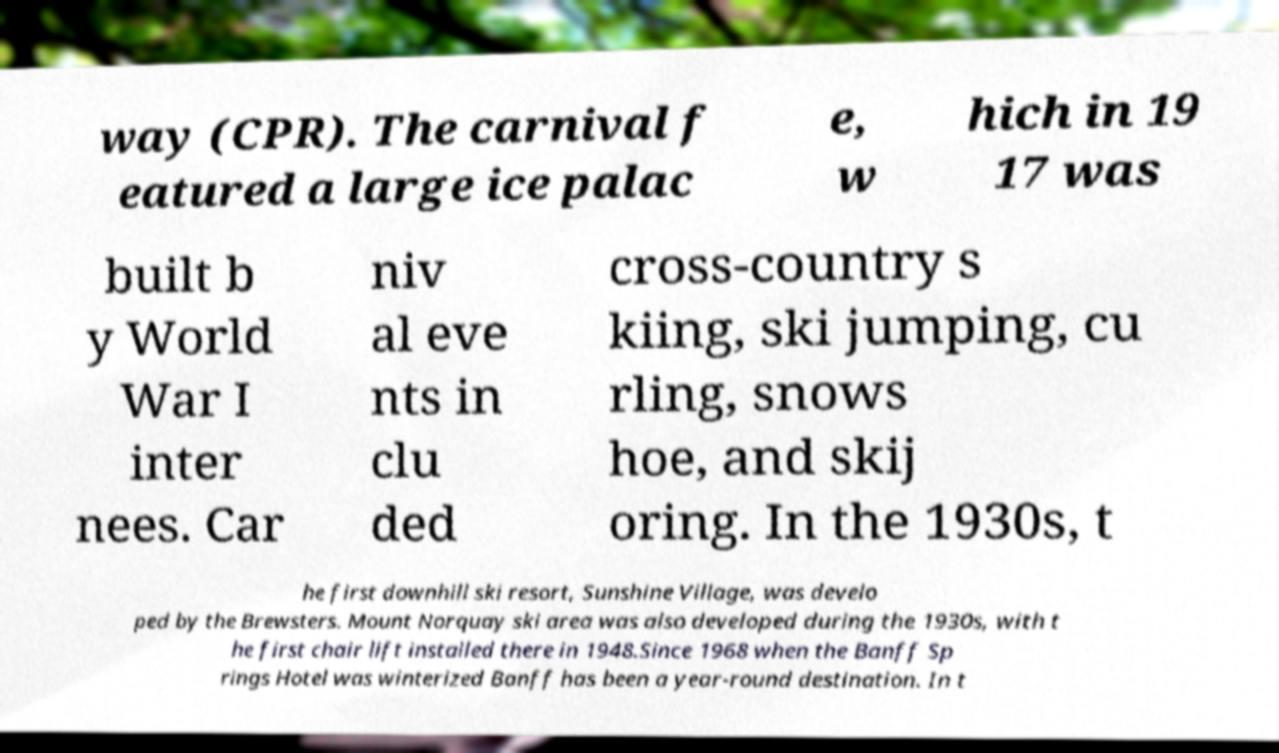Could you assist in decoding the text presented in this image and type it out clearly? way (CPR). The carnival f eatured a large ice palac e, w hich in 19 17 was built b y World War I inter nees. Car niv al eve nts in clu ded cross-country s kiing, ski jumping, cu rling, snows hoe, and skij oring. In the 1930s, t he first downhill ski resort, Sunshine Village, was develo ped by the Brewsters. Mount Norquay ski area was also developed during the 1930s, with t he first chair lift installed there in 1948.Since 1968 when the Banff Sp rings Hotel was winterized Banff has been a year-round destination. In t 